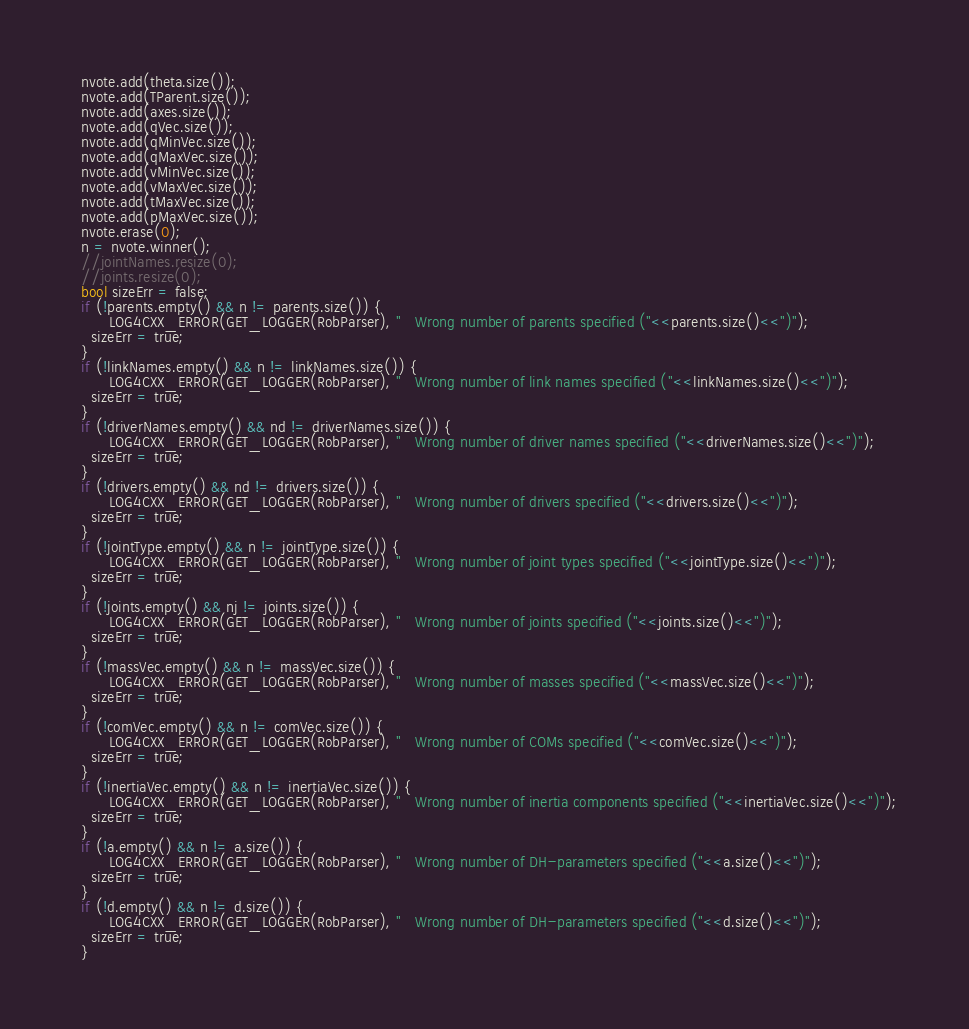<code> <loc_0><loc_0><loc_500><loc_500><_C++_>  nvote.add(theta.size());
  nvote.add(TParent.size());
  nvote.add(axes.size());
  nvote.add(qVec.size());
  nvote.add(qMinVec.size());
  nvote.add(qMaxVec.size());
  nvote.add(vMinVec.size());
  nvote.add(vMaxVec.size());
  nvote.add(tMaxVec.size());
  nvote.add(pMaxVec.size());
  nvote.erase(0);
  n = nvote.winner();
  //jointNames.resize(0);
  //joints.resize(0);
  bool sizeErr = false;
  if (!parents.empty() && n != parents.size()) {
        LOG4CXX_ERROR(GET_LOGGER(RobParser), "   Wrong number of parents specified ("<<parents.size()<<")");
    sizeErr = true;
  }
  if (!linkNames.empty() && n != linkNames.size()) {
        LOG4CXX_ERROR(GET_LOGGER(RobParser), "   Wrong number of link names specified ("<<linkNames.size()<<")");
    sizeErr = true;
  }
  if (!driverNames.empty() && nd != driverNames.size()) {
        LOG4CXX_ERROR(GET_LOGGER(RobParser), "   Wrong number of driver names specified ("<<driverNames.size()<<")");
    sizeErr = true;
  }
  if (!drivers.empty() && nd != drivers.size()) {
        LOG4CXX_ERROR(GET_LOGGER(RobParser), "   Wrong number of drivers specified ("<<drivers.size()<<")");
    sizeErr = true;
  }
  if (!jointType.empty() && n != jointType.size()) {
        LOG4CXX_ERROR(GET_LOGGER(RobParser), "   Wrong number of joint types specified ("<<jointType.size()<<")");
    sizeErr = true;
  }
  if (!joints.empty() && nj != joints.size()) {
        LOG4CXX_ERROR(GET_LOGGER(RobParser), "   Wrong number of joints specified ("<<joints.size()<<")");
    sizeErr = true;
  }
  if (!massVec.empty() && n != massVec.size()) {
        LOG4CXX_ERROR(GET_LOGGER(RobParser), "   Wrong number of masses specified ("<<massVec.size()<<")");
    sizeErr = true;
  }
  if (!comVec.empty() && n != comVec.size()) {
        LOG4CXX_ERROR(GET_LOGGER(RobParser), "   Wrong number of COMs specified ("<<comVec.size()<<")");
    sizeErr = true;
  }
  if (!inertiaVec.empty() && n != inertiaVec.size()) {
        LOG4CXX_ERROR(GET_LOGGER(RobParser), "   Wrong number of inertia components specified ("<<inertiaVec.size()<<")");
    sizeErr = true;
  }
  if (!a.empty() && n != a.size()) {
        LOG4CXX_ERROR(GET_LOGGER(RobParser), "   Wrong number of DH-parameters specified ("<<a.size()<<")");
    sizeErr = true;
  }
  if (!d.empty() && n != d.size()) {
        LOG4CXX_ERROR(GET_LOGGER(RobParser), "   Wrong number of DH-parameters specified ("<<d.size()<<")");
    sizeErr = true;
  }</code> 